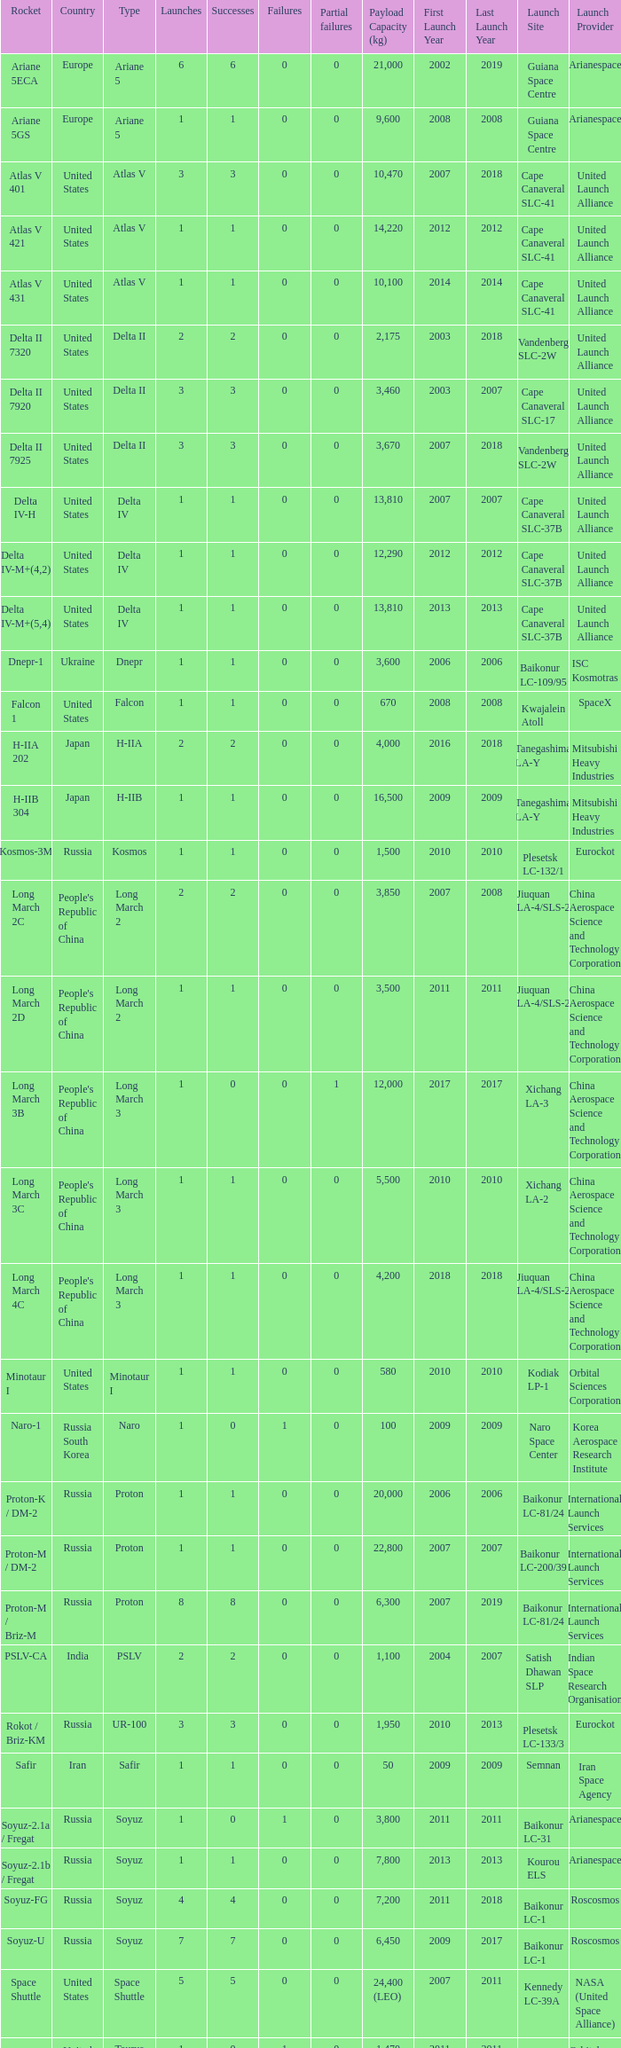What's the total failures among rockets that had more than 3 successes, type ariane 5 and more than 0 partial failures? 0.0. 